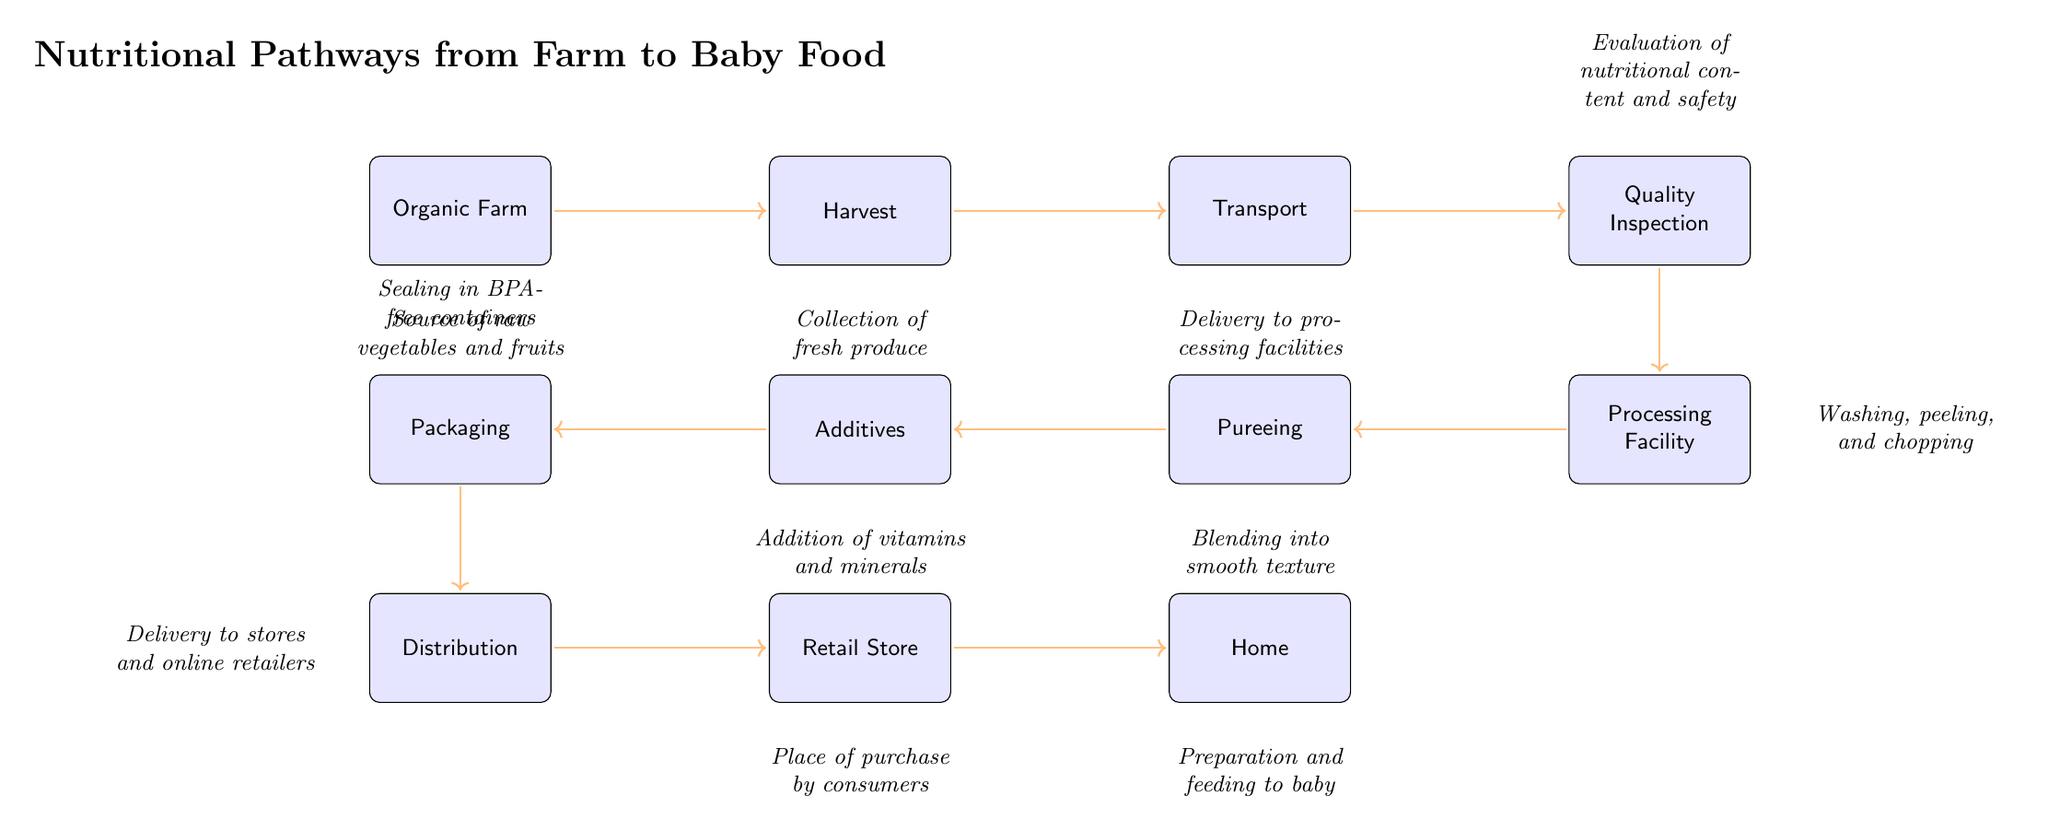What is the first step in the food chain? The diagram indicates that the first step is the "Organic Farm," which serves as the source of raw vegetables and fruits used in baby food.
Answer: Organic Farm What is the last step in the food chain? The final step is "Home," where the prepared food is given to the baby.
Answer: Home How many processes are there from farm to baby food? By counting all the nodes in the diagram, there are a total of ten distinct processes involved in transforming farm produce into baby food.
Answer: Ten Which node comes after "Processing Facility"? The diagram shows that after "Processing Facility," the next step is "Pureeing," which involves blending the produce into a smooth texture.
Answer: Pureeing What process involves adding vitamins and minerals? The step that incorporates the addition of vitamins and minerals is labeled "Additives," which follows the "Pureeing" stage in the food chain.
Answer: Additives What happens right before the food reaches the retail store? Right before reaching the "Retail Store," the food undergoes the "Distribution" process. This involves the delivery of products to stores and online retailers.
Answer: Distribution Which node evaluates nutritional content and safety? The node responsible for evaluating nutritional content and safety is "Quality Inspection." This step is crucial before processing the harvested produce.
Answer: Quality Inspection What is done during the "Pureeing" process? The "Pureeing" process involves blending the vegetables and fruits into a smooth texture, making it suitable for baby food.
Answer: Blending into smooth texture What type of containers are used for packaging? The packaging process involves sealing the food in BPA-free containers, ensuring safety for infants.
Answer: BPA-free containers 